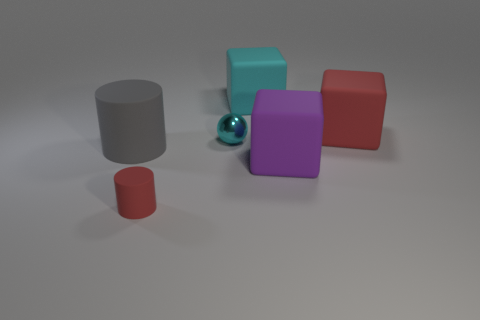Can you tell me the colors of the objects excluding the sphere? Excluding the sphere, the objects' colors are gray, teal, purple, and red. 